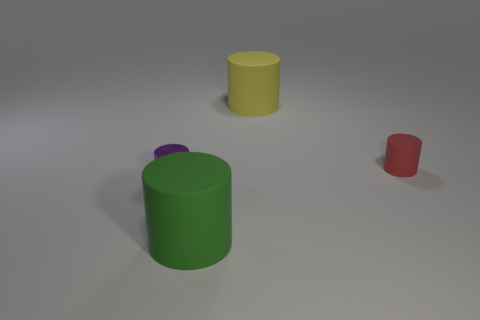What number of matte things are either tiny purple cylinders or large cyan cubes?
Provide a succinct answer. 0. Do the metal thing and the yellow cylinder have the same size?
Your answer should be very brief. No. How many things are big green cylinders or tiny objects to the left of the red rubber object?
Provide a short and direct response. 2. There is a green thing that is the same size as the yellow matte thing; what material is it?
Make the answer very short. Rubber. What is the material of the cylinder that is both to the right of the shiny cylinder and in front of the tiny red rubber cylinder?
Keep it short and to the point. Rubber. There is a rubber cylinder that is in front of the tiny red object; are there any small purple cylinders that are right of it?
Your answer should be very brief. No. How big is the cylinder that is on the left side of the big yellow matte thing and right of the small purple cylinder?
Your answer should be very brief. Large. What number of blue things are cylinders or large rubber objects?
Provide a short and direct response. 0. There is a yellow object that is the same size as the green cylinder; what shape is it?
Your answer should be very brief. Cylinder. What number of other things are the same color as the metallic cylinder?
Your answer should be very brief. 0. 